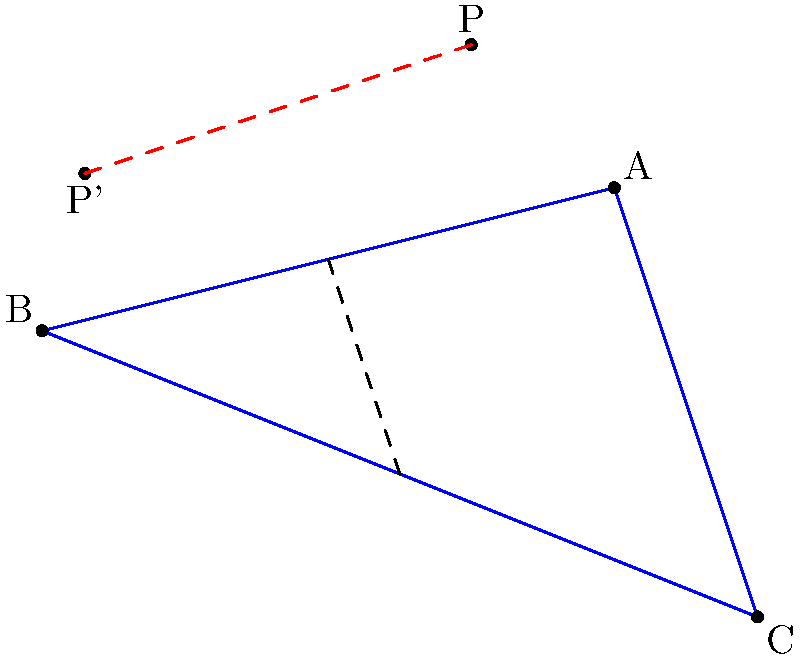In the architectural sketch above, triangle ABC represents the facade of a modernist building. Point P represents a sculpture installation. The dashed line MN is a line of symmetry for the building's design. If P is reflected across line MN to create P', what are the coordinates of P'? To find the coordinates of P', we need to reflect point P across line MN. Let's approach this step-by-step:

1) First, we need to find the equation of line MN. 
   M is the midpoint of AB: $M = (\frac{1-3}{2}, \frac{2+1}{2}) = (-1, \frac{3}{2})$
   N is the midpoint of BC: $N = (\frac{-3+2}{2}, \frac{1-1}{2}) = (-\frac{1}{2}, 0)$

2) The slope of MN is:
   $m = \frac{0-\frac{3}{2}}{-\frac{1}{2}-(-1)} = -3$

3) The equation of line MN is:
   $y - \frac{3}{2} = -3(x + 1)$ or $y = -3x - \frac{3}{2}$

4) To reflect P(0,3) across this line, we can use the reflection formula:
   $x' = \frac{(1-m^2)x + 2m(y-b)}{1+m^2}$
   $y' = \frac{2mx - (1-m^2)(y-b)}{1+m^2} + b$

   Where $(x,y)$ are the coordinates of P, $(x',y')$ are the coordinates of P', $m$ is the slope of MN, and $b$ is the y-intercept of MN.

5) Substituting the values:
   $x' = \frac{(1-(-3)^2)(0) + 2(-3)(3-(-\frac{3}{2}))}{1+(-3)^2} = -\frac{27}{10} = -2.7$

   $y' = \frac{2(-3)(0) - (1-(-3)^2)(3-(-\frac{3}{2}))}{1+(-3)^2} + (-\frac{3}{2}) = -\frac{21}{10} = -2.1$

6) Therefore, the coordinates of P' are $(-2.7, -2.1)$.
Answer: $(-2.7, -2.1)$ 